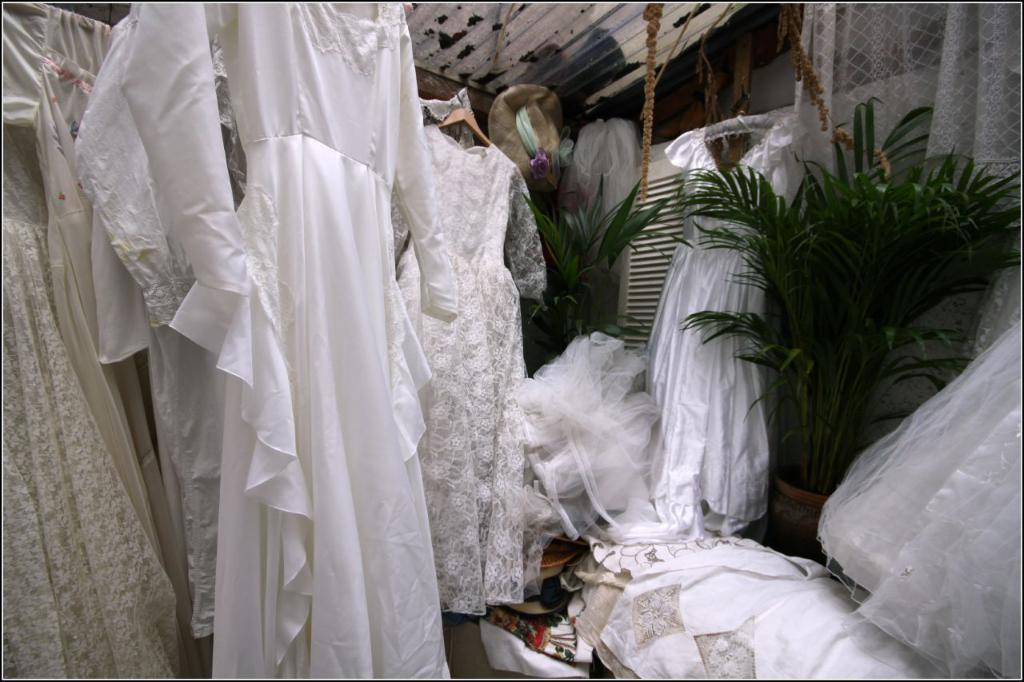What objects are present in the image? There are clothes and two plants in the middle of the image. Can you describe the plants in the image? The plants are located in the middle of the image. What is visible in the background of the image? There is a curtain in the background of the image. How is the oil distributed among the clothes in the image? There is no oil present in the image; it only features clothes and plants. 